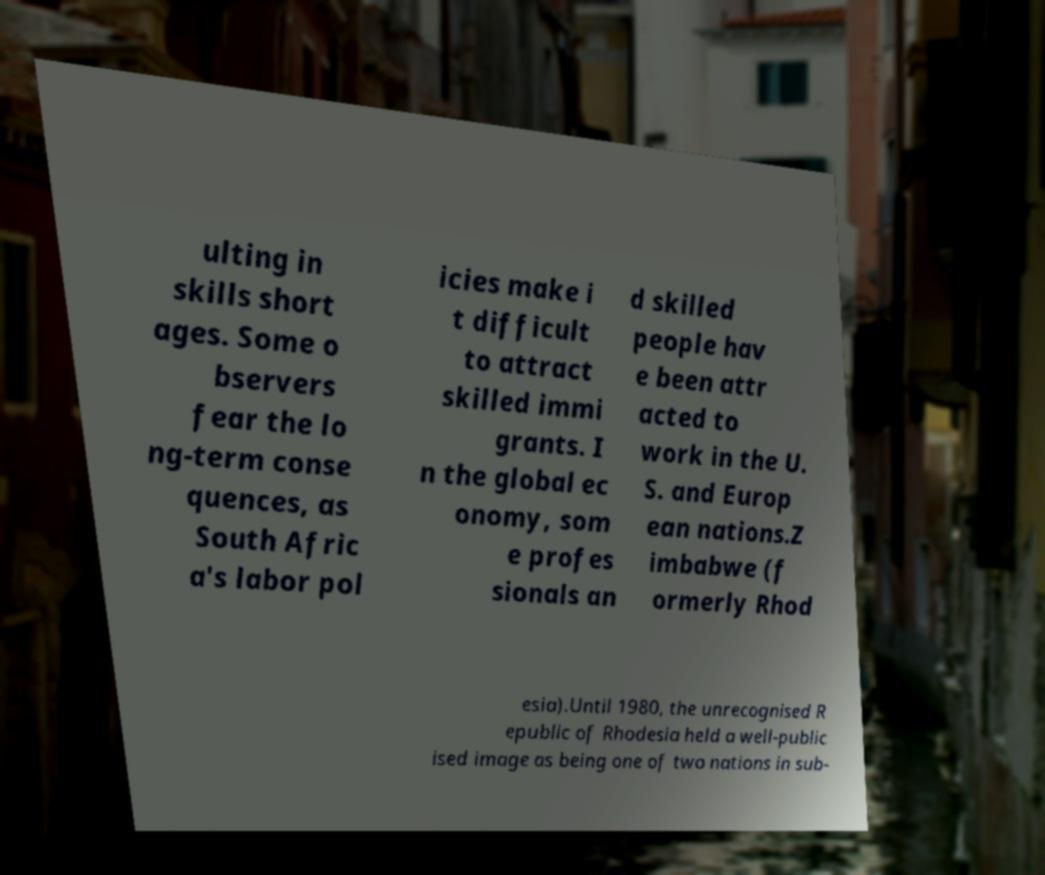There's text embedded in this image that I need extracted. Can you transcribe it verbatim? ulting in skills short ages. Some o bservers fear the lo ng-term conse quences, as South Afric a's labor pol icies make i t difficult to attract skilled immi grants. I n the global ec onomy, som e profes sionals an d skilled people hav e been attr acted to work in the U. S. and Europ ean nations.Z imbabwe (f ormerly Rhod esia).Until 1980, the unrecognised R epublic of Rhodesia held a well-public ised image as being one of two nations in sub- 